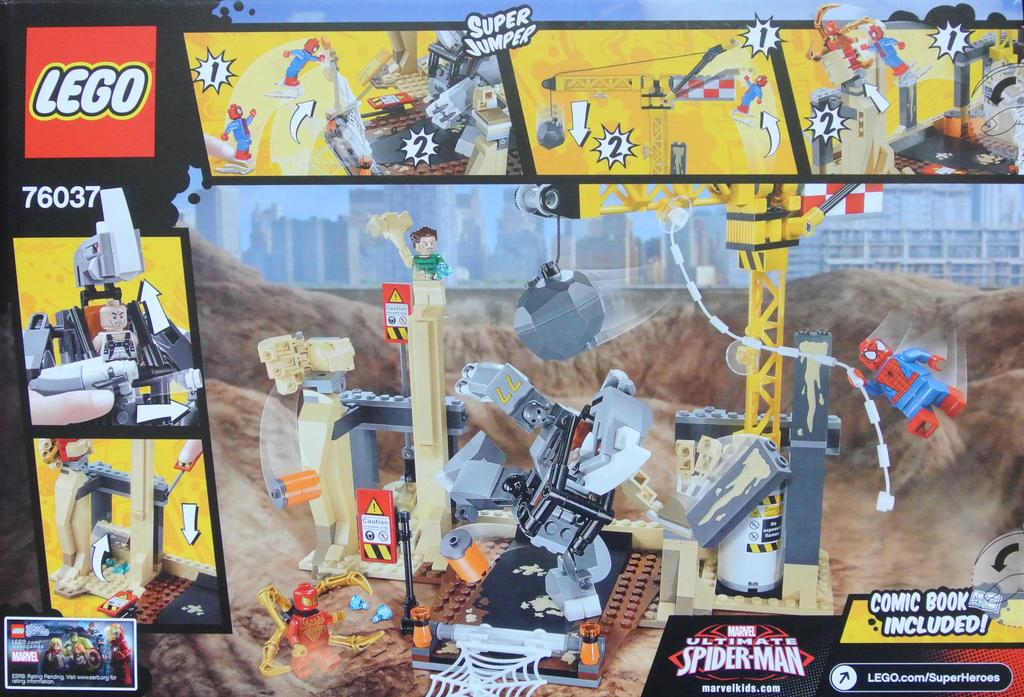What type of structures can be seen in the image? There are buildings in the image. What part of the natural environment is visible in the image? The sky is visible in the image. What type of objects are present in the image? There are toys in the image. What type of symbols or designs can be seen in the image? There are logos in the image. What else can be seen in the image besides the mentioned elements? There are other pictures in the image. Is there any text present in the image? Yes, there is something written in the image. Can you tell me how many daughters are visible in the image? There is no mention of a daughter or any people in the image; it features buildings, the sky, toys, logos, other pictures, and written text. Is there a camera visible in the image? There is no camera present in the image. 